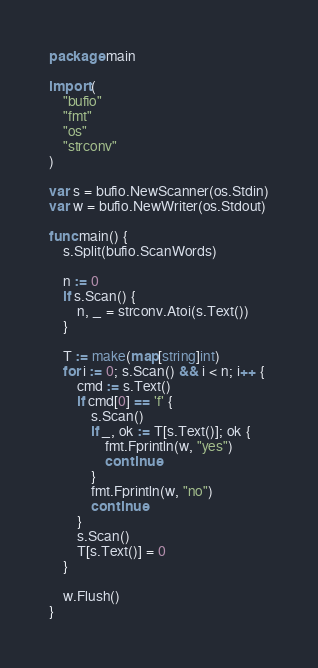Convert code to text. <code><loc_0><loc_0><loc_500><loc_500><_Go_>package main

import (
	"bufio"
	"fmt"
	"os"
	"strconv"
)

var s = bufio.NewScanner(os.Stdin)
var w = bufio.NewWriter(os.Stdout)

func main() {
	s.Split(bufio.ScanWords)

	n := 0
	if s.Scan() {
		n, _ = strconv.Atoi(s.Text())
	}

	T := make(map[string]int)
	for i := 0; s.Scan() && i < n; i++ {
		cmd := s.Text()
		if cmd[0] == 'f' {
			s.Scan()
			if _, ok := T[s.Text()]; ok {
				fmt.Fprintln(w, "yes")
				continue
			}
			fmt.Fprintln(w, "no")
			continue
		}
		s.Scan()
		T[s.Text()] = 0
	}

	w.Flush()
}

</code> 